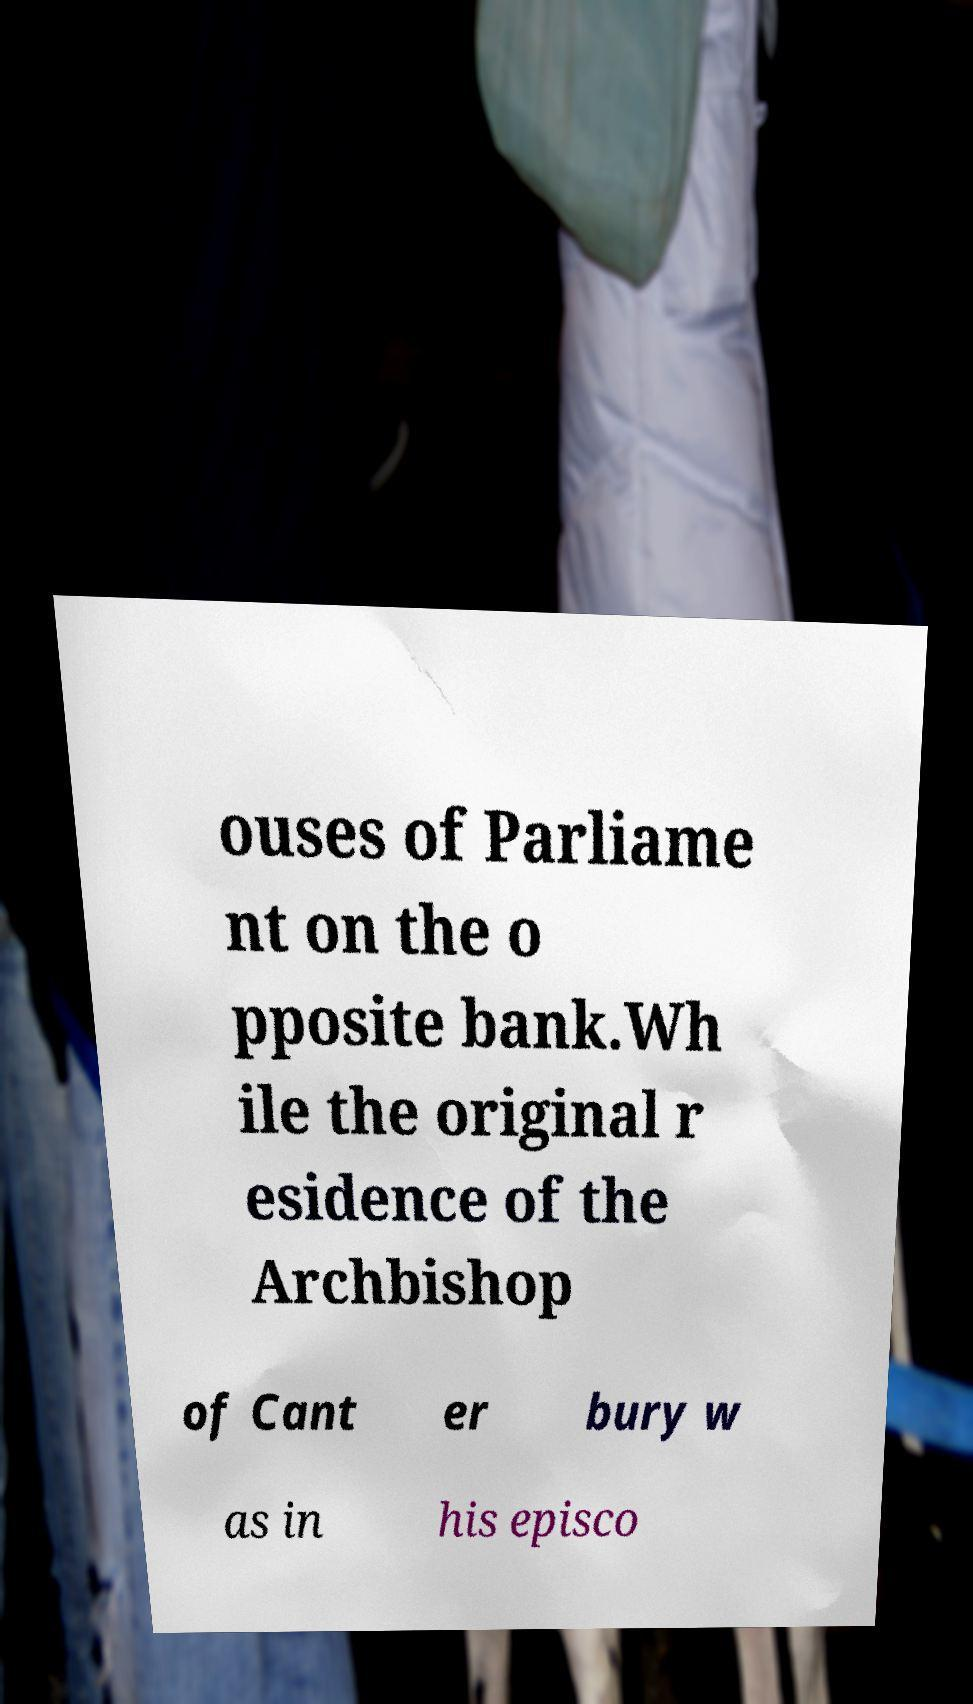Please read and relay the text visible in this image. What does it say? ouses of Parliame nt on the o pposite bank.Wh ile the original r esidence of the Archbishop of Cant er bury w as in his episco 